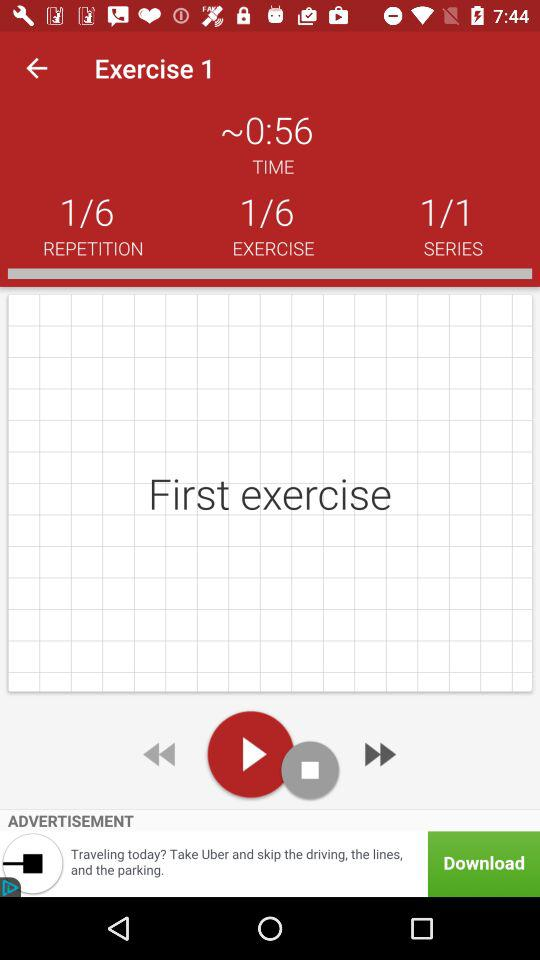How many exercise series are there? There is 1 exercise series. 